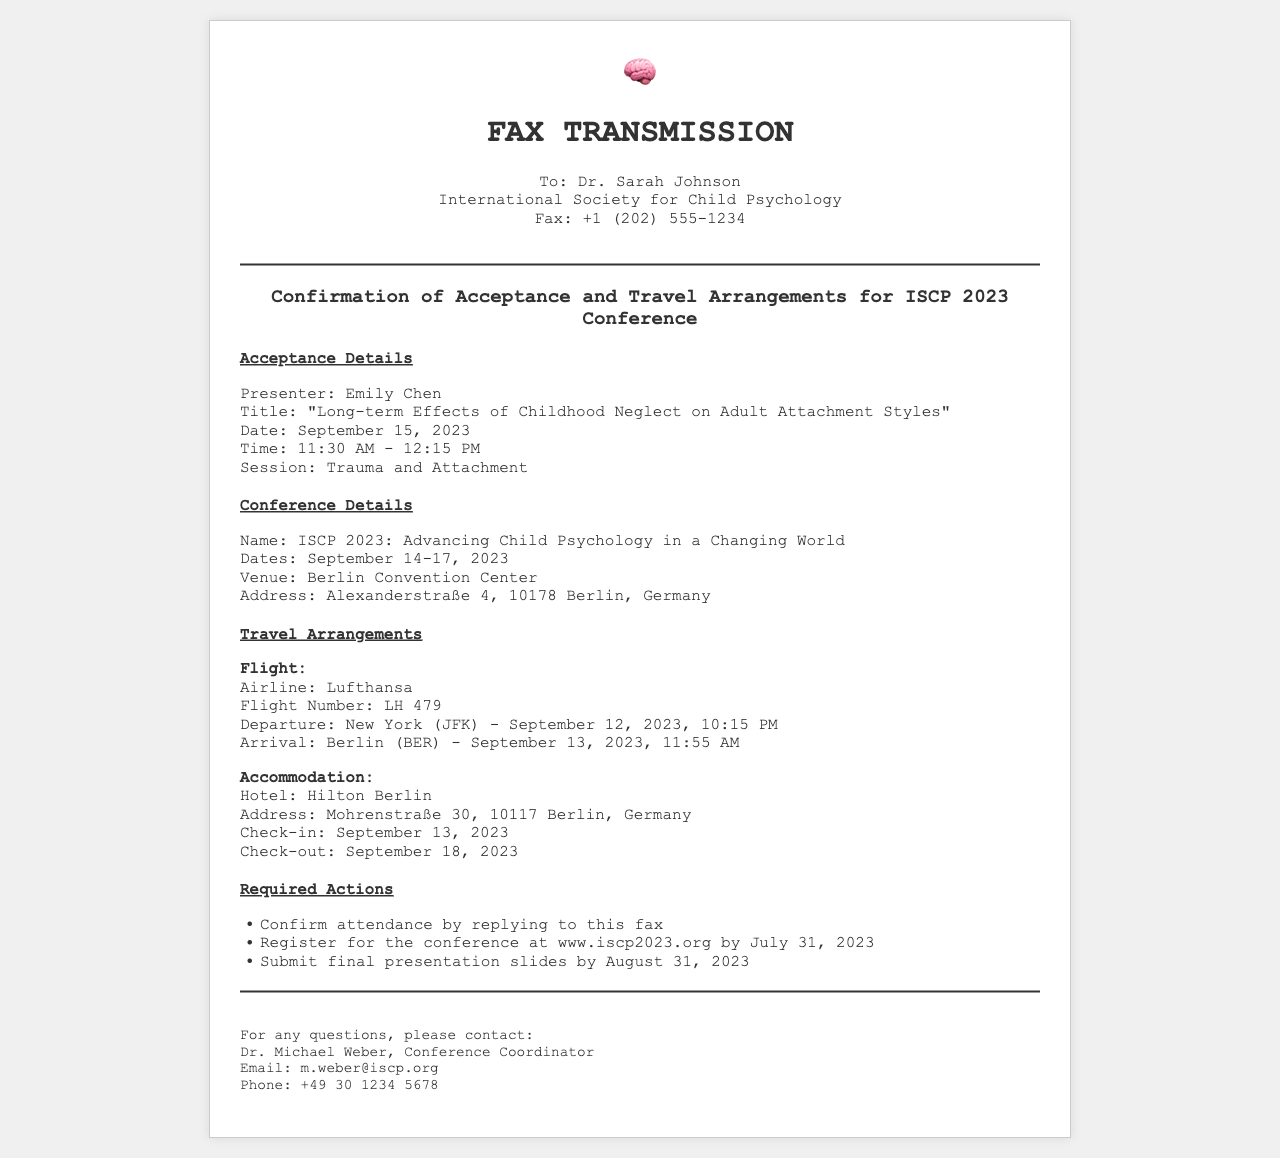What is the title of the presentation? The title of the presentation is mentioned under the acceptance details section.
Answer: "Long-term Effects of Childhood Neglect on Adult Attachment Styles" Who is the presenter? The name of the presenter is listed in the acceptance details section.
Answer: Emily Chen What are the conference dates? The dates for the conference are given in the conference details section.
Answer: September 14-17, 2023 What airline is being used for the flight? The airline for the flight is specified in the travel arrangements section.
Answer: Lufthansa What is the check-out date from the hotel? The check-out date is provided in the travel arrangements section regarding accommodation.
Answer: September 18, 2023 What is the session title for the presentation? The session title is indicated in the acceptance details section.
Answer: Trauma and Attachment How many actions need to be confirmed? The number of required actions is calculated by counting the items in the required actions section.
Answer: Three What is the location of the conference venue? The address of the conference venue is found in the conference details section.
Answer: Alexanderstraße 4, 10178 Berlin, Germany What is the registration deadline for the conference? The registration deadline is listed in the required actions section.
Answer: July 31, 2023 